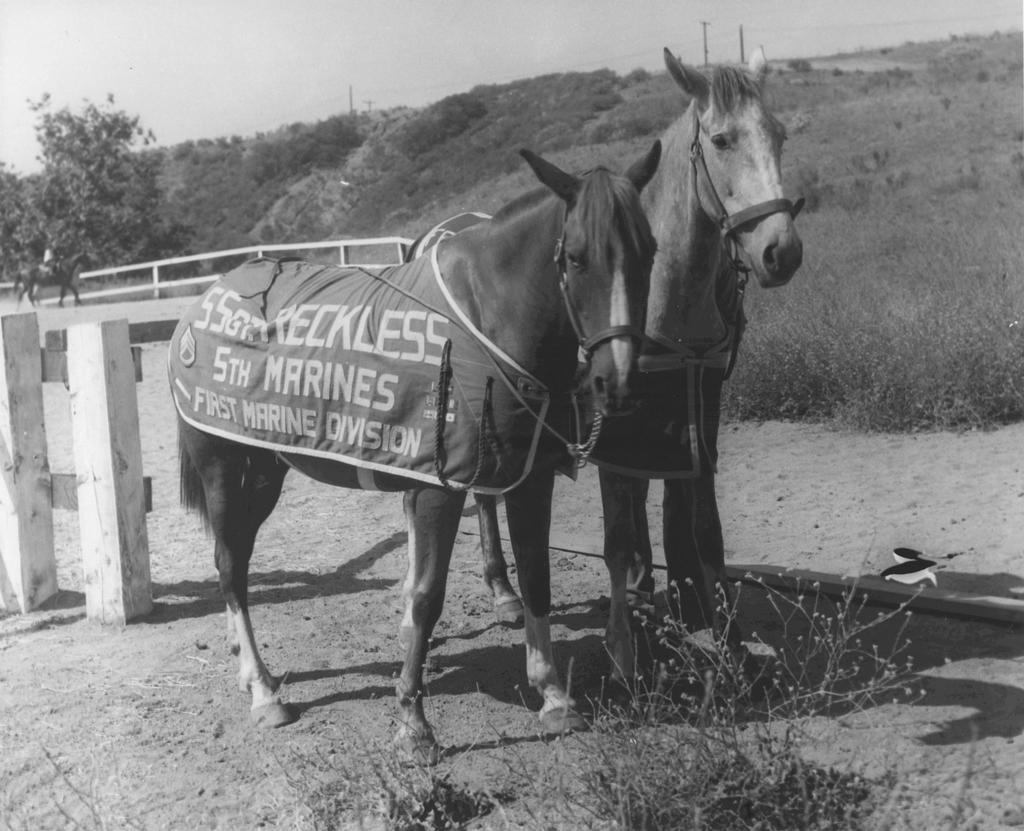How many horses are present in the image? There are two horses standing in the image. What is attached to one or both of the horses? A cloth is tightened to one or both of the horses. What is written on the cloth? There is writing on the cloth. What type of natural scenery can be seen in the image? There are trees visible in the image. Where is one of the horses located in the image? There is a horse in the left corner of the image. How many rings are visible on the pig's snout in the image? There is no pig or rings present in the image; it features two horses with a cloth. 